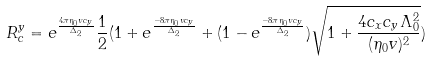<formula> <loc_0><loc_0><loc_500><loc_500>R _ { c } ^ { y } = e ^ { \frac { 4 \pi \eta _ { 0 } v c _ { y } } { \Delta _ { 2 } } } \frac { 1 } { 2 } ( 1 + e ^ { \frac { - 8 \pi \eta _ { 0 } v c _ { y } } { \Delta _ { 2 } } } + ( 1 - e ^ { \frac { - 8 \pi \eta _ { 0 } v c _ { y } } { \Delta _ { 2 } } } ) \sqrt { 1 + \frac { 4 c _ { x } c _ { y } \Lambda _ { 0 } ^ { 2 } } { ( \eta _ { 0 } v ) ^ { 2 } } } )</formula> 